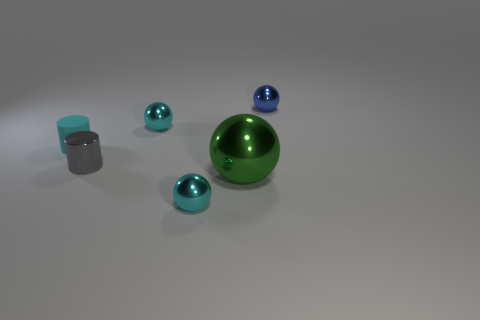Add 1 tiny gray metallic objects. How many objects exist? 7 Subtract all cylinders. How many objects are left? 4 Add 1 tiny gray objects. How many tiny gray objects are left? 2 Add 3 tiny gray metal cylinders. How many tiny gray metal cylinders exist? 4 Subtract 0 gray blocks. How many objects are left? 6 Subtract all small rubber cylinders. Subtract all cyan cylinders. How many objects are left? 4 